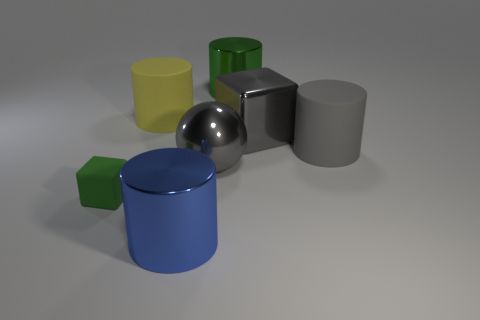Add 1 metal cylinders. How many objects exist? 8 Subtract all gray cylinders. How many cylinders are left? 3 Subtract all gray cylinders. Subtract all red cubes. How many cylinders are left? 3 Add 5 big green shiny cylinders. How many big green shiny cylinders are left? 6 Add 3 cubes. How many cubes exist? 5 Subtract 0 brown spheres. How many objects are left? 7 Subtract all cubes. How many objects are left? 5 Subtract all big green rubber spheres. Subtract all large metal objects. How many objects are left? 3 